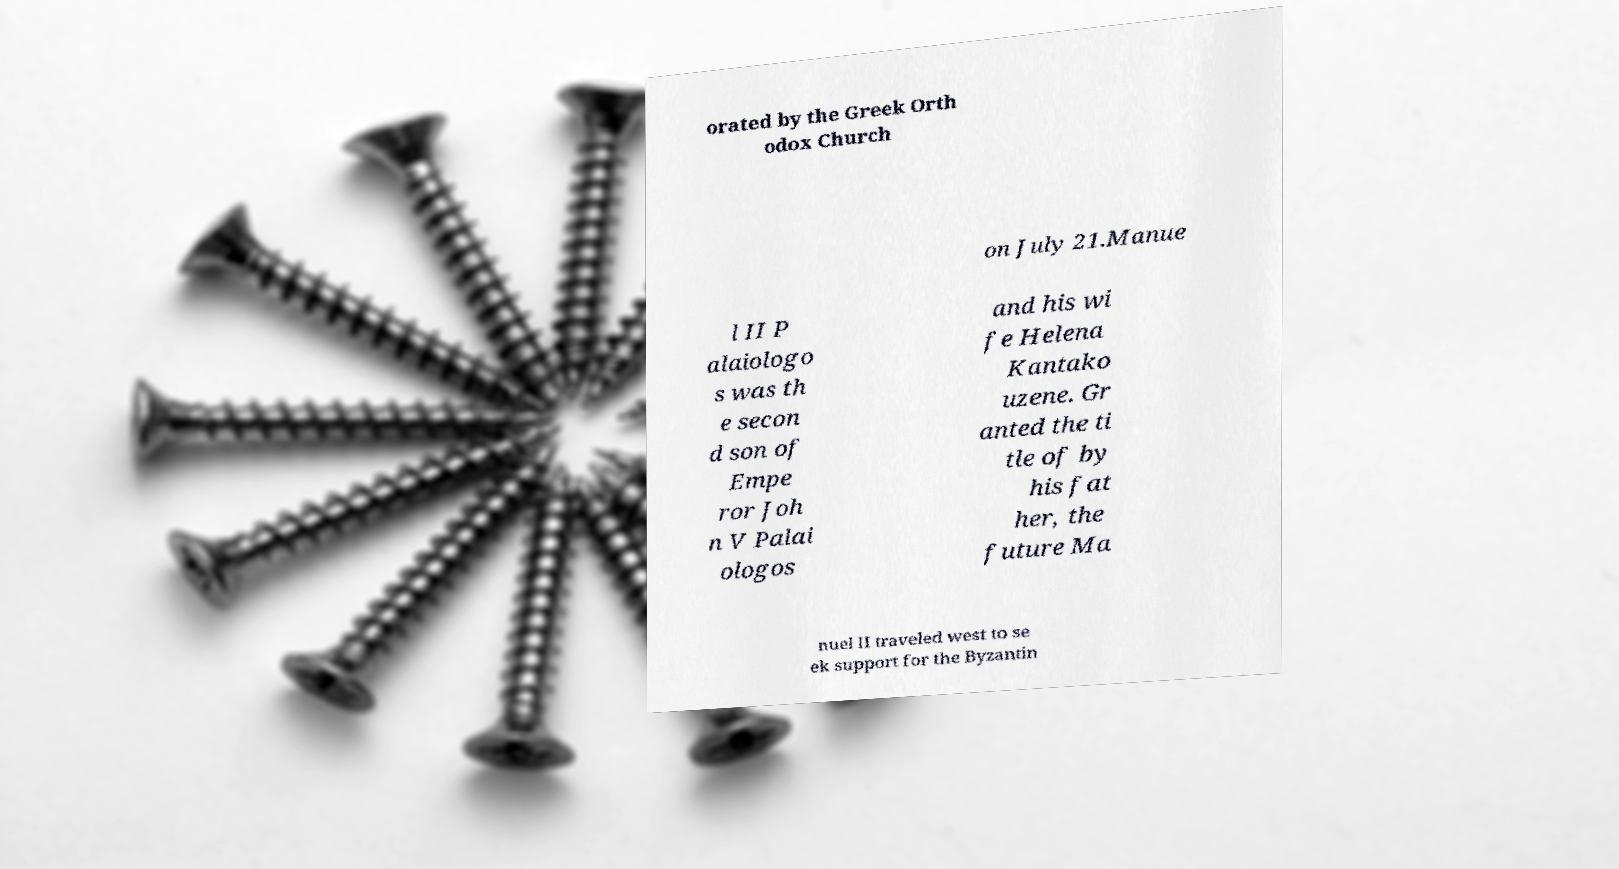What messages or text are displayed in this image? I need them in a readable, typed format. orated by the Greek Orth odox Church on July 21.Manue l II P alaiologo s was th e secon d son of Empe ror Joh n V Palai ologos and his wi fe Helena Kantako uzene. Gr anted the ti tle of by his fat her, the future Ma nuel II traveled west to se ek support for the Byzantin 